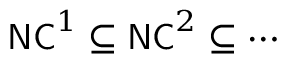Convert formula to latex. <formula><loc_0><loc_0><loc_500><loc_500>{ N C } ^ { 1 } \subseteq { N C } ^ { 2 } \subseteq \cdots</formula> 